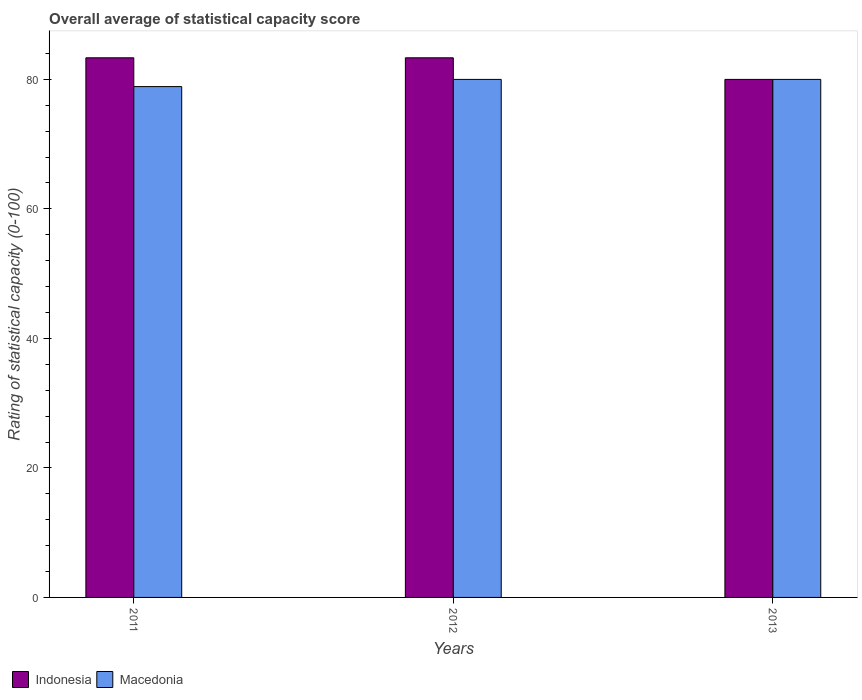Are the number of bars per tick equal to the number of legend labels?
Ensure brevity in your answer.  Yes. How many bars are there on the 1st tick from the right?
Ensure brevity in your answer.  2. In how many cases, is the number of bars for a given year not equal to the number of legend labels?
Offer a very short reply. 0. What is the rating of statistical capacity in Macedonia in 2012?
Ensure brevity in your answer.  80. Across all years, what is the maximum rating of statistical capacity in Indonesia?
Offer a very short reply. 83.33. Across all years, what is the minimum rating of statistical capacity in Indonesia?
Offer a very short reply. 80. In which year was the rating of statistical capacity in Macedonia minimum?
Offer a terse response. 2011. What is the total rating of statistical capacity in Macedonia in the graph?
Provide a succinct answer. 238.89. What is the difference between the rating of statistical capacity in Indonesia in 2011 and the rating of statistical capacity in Macedonia in 2013?
Your answer should be very brief. 3.33. What is the average rating of statistical capacity in Indonesia per year?
Make the answer very short. 82.22. In the year 2012, what is the difference between the rating of statistical capacity in Indonesia and rating of statistical capacity in Macedonia?
Keep it short and to the point. 3.33. What is the ratio of the rating of statistical capacity in Macedonia in 2011 to that in 2012?
Offer a terse response. 0.99. Is the rating of statistical capacity in Indonesia in 2012 less than that in 2013?
Give a very brief answer. No. What is the difference between the highest and the second highest rating of statistical capacity in Indonesia?
Keep it short and to the point. 0. What is the difference between the highest and the lowest rating of statistical capacity in Macedonia?
Offer a very short reply. 1.11. What does the 1st bar from the right in 2012 represents?
Offer a terse response. Macedonia. How many bars are there?
Provide a short and direct response. 6. How many years are there in the graph?
Provide a succinct answer. 3. Are the values on the major ticks of Y-axis written in scientific E-notation?
Give a very brief answer. No. Does the graph contain grids?
Your answer should be compact. No. Where does the legend appear in the graph?
Your answer should be compact. Bottom left. How many legend labels are there?
Provide a short and direct response. 2. How are the legend labels stacked?
Offer a very short reply. Horizontal. What is the title of the graph?
Keep it short and to the point. Overall average of statistical capacity score. What is the label or title of the Y-axis?
Keep it short and to the point. Rating of statistical capacity (0-100). What is the Rating of statistical capacity (0-100) of Indonesia in 2011?
Keep it short and to the point. 83.33. What is the Rating of statistical capacity (0-100) of Macedonia in 2011?
Your response must be concise. 78.89. What is the Rating of statistical capacity (0-100) of Indonesia in 2012?
Your answer should be very brief. 83.33. Across all years, what is the maximum Rating of statistical capacity (0-100) in Indonesia?
Offer a terse response. 83.33. Across all years, what is the minimum Rating of statistical capacity (0-100) in Macedonia?
Ensure brevity in your answer.  78.89. What is the total Rating of statistical capacity (0-100) of Indonesia in the graph?
Make the answer very short. 246.67. What is the total Rating of statistical capacity (0-100) in Macedonia in the graph?
Provide a short and direct response. 238.89. What is the difference between the Rating of statistical capacity (0-100) in Macedonia in 2011 and that in 2012?
Ensure brevity in your answer.  -1.11. What is the difference between the Rating of statistical capacity (0-100) in Macedonia in 2011 and that in 2013?
Your answer should be very brief. -1.11. What is the difference between the Rating of statistical capacity (0-100) of Indonesia in 2012 and that in 2013?
Offer a terse response. 3.33. What is the difference between the Rating of statistical capacity (0-100) of Indonesia in 2011 and the Rating of statistical capacity (0-100) of Macedonia in 2012?
Your answer should be compact. 3.33. What is the difference between the Rating of statistical capacity (0-100) in Indonesia in 2011 and the Rating of statistical capacity (0-100) in Macedonia in 2013?
Ensure brevity in your answer.  3.33. What is the average Rating of statistical capacity (0-100) in Indonesia per year?
Give a very brief answer. 82.22. What is the average Rating of statistical capacity (0-100) in Macedonia per year?
Make the answer very short. 79.63. In the year 2011, what is the difference between the Rating of statistical capacity (0-100) in Indonesia and Rating of statistical capacity (0-100) in Macedonia?
Make the answer very short. 4.44. What is the ratio of the Rating of statistical capacity (0-100) in Indonesia in 2011 to that in 2012?
Your answer should be compact. 1. What is the ratio of the Rating of statistical capacity (0-100) of Macedonia in 2011 to that in 2012?
Offer a very short reply. 0.99. What is the ratio of the Rating of statistical capacity (0-100) of Indonesia in 2011 to that in 2013?
Your answer should be very brief. 1.04. What is the ratio of the Rating of statistical capacity (0-100) of Macedonia in 2011 to that in 2013?
Your answer should be compact. 0.99. What is the ratio of the Rating of statistical capacity (0-100) in Indonesia in 2012 to that in 2013?
Keep it short and to the point. 1.04. What is the ratio of the Rating of statistical capacity (0-100) in Macedonia in 2012 to that in 2013?
Provide a succinct answer. 1. What is the difference between the highest and the second highest Rating of statistical capacity (0-100) of Macedonia?
Your answer should be very brief. 0. 